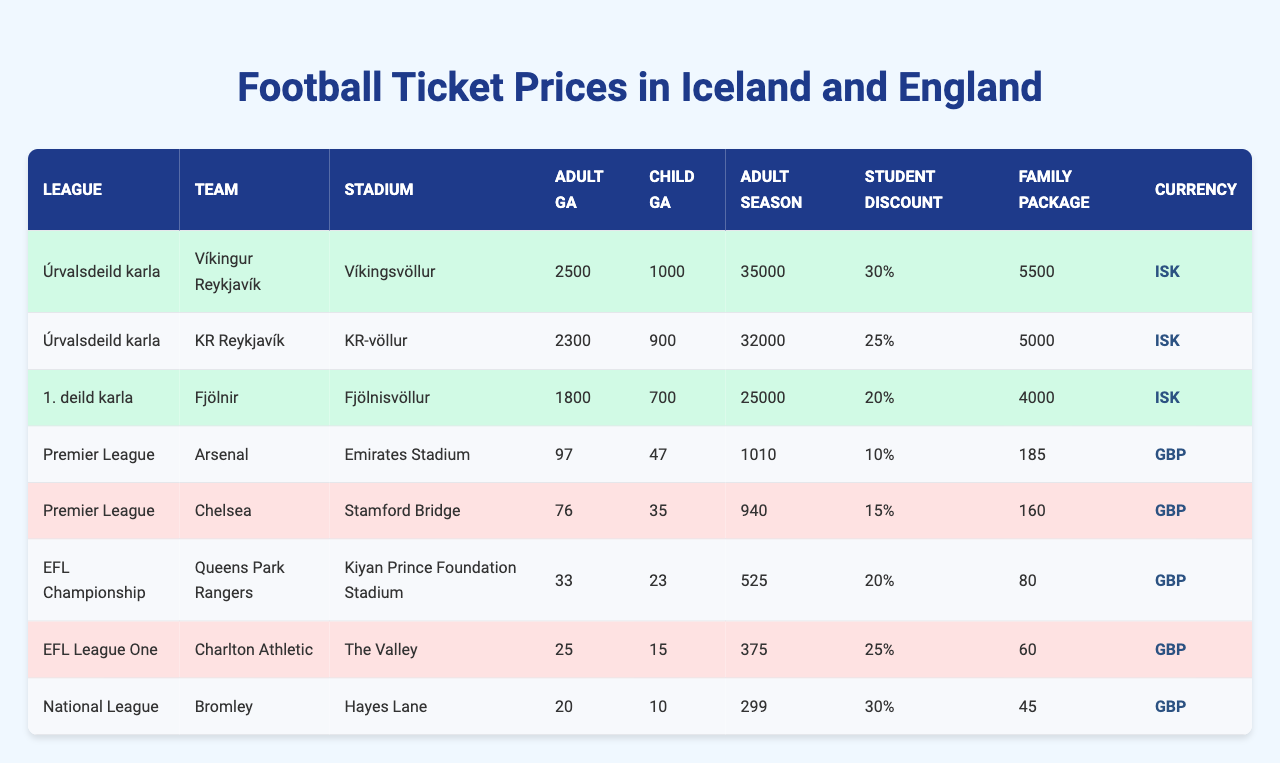What is the adult general admission price for KR Reykjavík? The table shows that the adult general admission price for KR Reykjavík is 2300 ISK.
Answer: 2300 ISK Which team has the highest adult season ticket price? By comparing the prices listed under adult season ticket, Arsenal has the highest price at 1010 GBP.
Answer: Arsenal Is the family package price cheaper for English teams than Icelandic teams? The family package prices for Icelandic teams (5500 ISK, 5000 ISK, 4000 ISK) convert to roughly 37 GBP, while the lowest English family package price is 45 GBP. Therefore, on average, Icelandic teams offer cheaper prices.
Answer: Yes What percentage discount do students get for tickets at Fjölnir? The student discount for Fjölnir is listed as 20%.
Answer: 20% What is the average adult general admission price for teams in the EFL Championship? The adult general admission prices for teams in the EFL Championship (Queens Park Rangers and Charlton Athletic) are 33 GBP and 25 GBP. The average is (33 + 25)/2 = 29 GBP.
Answer: 29 GBP What is the difference in price for adult general admission between Bumbley and Chelsea? The adult general admission price for Bromley is 20 GBP and for Chelsea is 76 GBP. The difference is 76 - 20 = 56 GBP.
Answer: 56 GBP Which league offers the lowest price for a family package? The prices for family packages are 5500 ISK, 5000 ISK, 4000 ISK for Icelandic teams and 185, 160, 80, 60, 45 for English teams. The lowest price is 45 GBP from Bromley.
Answer: 45 GBP How much more does it cost to buy an adult season ticket for KR Reykjavík compared to Bromley? The adult season ticket price for KR Reykjavík is 32000 ISK (about 215 GBP) while for Bromley it is 299 GBP. The cost difference is 299 - 215 = 84 GBP.
Answer: 84 GBP Do Arsenal and Chelsea have the same child general admission prices? Arsenal's child general admission price is 47 GBP while Chelsea's is 35 GBP, meaning they do not have the same price.
Answer: No Which Icelandic team has the lowest adult general admission price? By looking at the adult general admission prices for Icelandic teams (2500 ISK, 2300 ISK, 1800 ISK), Fjölnir has the lowest price at 1800 ISK.
Answer: Fjölnir 